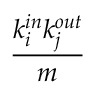<formula> <loc_0><loc_0><loc_500><loc_500>\frac { k _ { i } ^ { i n } k _ { j } ^ { o u t } } { m }</formula> 